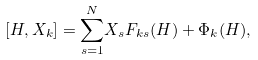<formula> <loc_0><loc_0><loc_500><loc_500>[ H , X _ { k } ] = { \sum _ { s = 1 } ^ { N } } X _ { s } F _ { k s } ( H ) + \Phi _ { k } ( H ) ,</formula> 